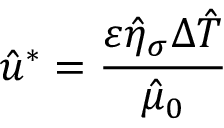Convert formula to latex. <formula><loc_0><loc_0><loc_500><loc_500>\hat { u } ^ { * } = \frac { \varepsilon \hat { \eta } _ { \sigma } \Delta \hat { T } } { \hat { \mu } _ { 0 } }</formula> 